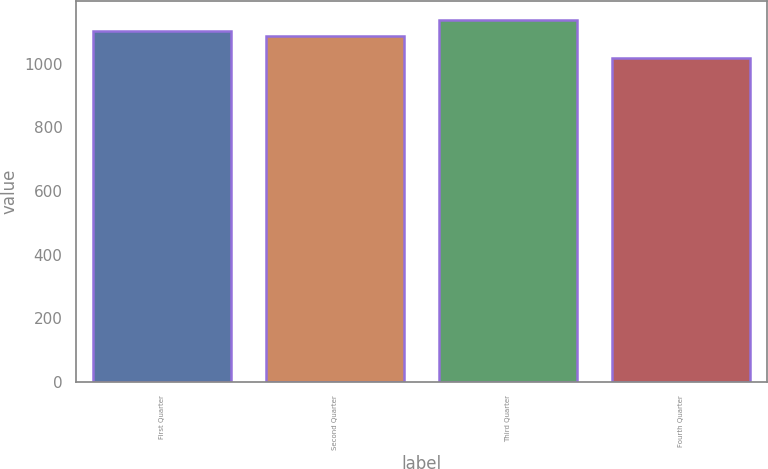Convert chart. <chart><loc_0><loc_0><loc_500><loc_500><bar_chart><fcel>First Quarter<fcel>Second Quarter<fcel>Third Quarter<fcel>Fourth Quarter<nl><fcel>1103.9<fcel>1087.26<fcel>1139.27<fcel>1017.28<nl></chart> 